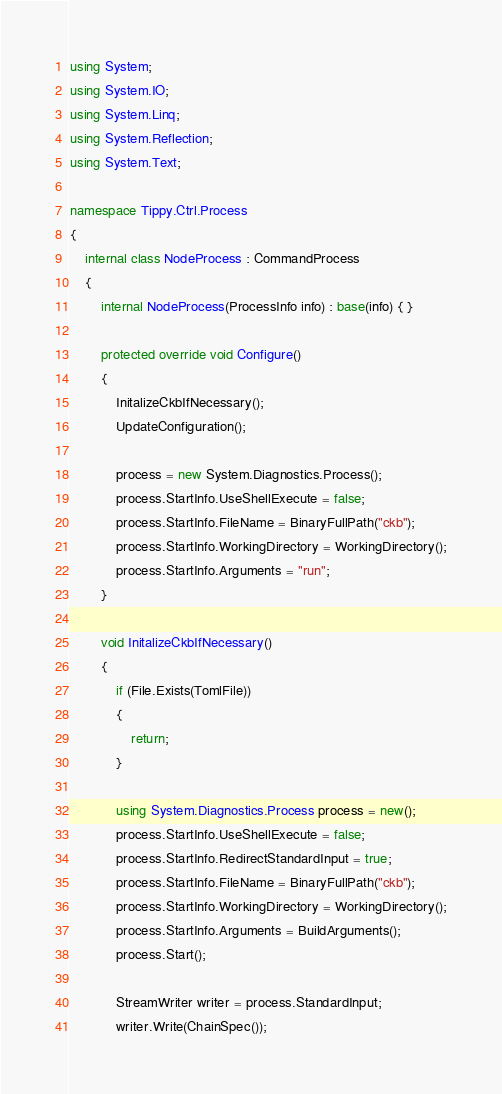<code> <loc_0><loc_0><loc_500><loc_500><_C#_>using System;
using System.IO;
using System.Linq;
using System.Reflection;
using System.Text;

namespace Tippy.Ctrl.Process
{
    internal class NodeProcess : CommandProcess
    {
        internal NodeProcess(ProcessInfo info) : base(info) { }

        protected override void Configure()
        {
            InitalizeCkbIfNecessary();
            UpdateConfiguration();

            process = new System.Diagnostics.Process();
            process.StartInfo.UseShellExecute = false;
            process.StartInfo.FileName = BinaryFullPath("ckb");
            process.StartInfo.WorkingDirectory = WorkingDirectory();
            process.StartInfo.Arguments = "run";
        }

        void InitalizeCkbIfNecessary()
        {
            if (File.Exists(TomlFile))
            {
                return;
            }

            using System.Diagnostics.Process process = new();
            process.StartInfo.UseShellExecute = false;
            process.StartInfo.RedirectStandardInput = true;
            process.StartInfo.FileName = BinaryFullPath("ckb");
            process.StartInfo.WorkingDirectory = WorkingDirectory();
            process.StartInfo.Arguments = BuildArguments();
            process.Start();

            StreamWriter writer = process.StandardInput;
            writer.Write(ChainSpec());</code> 